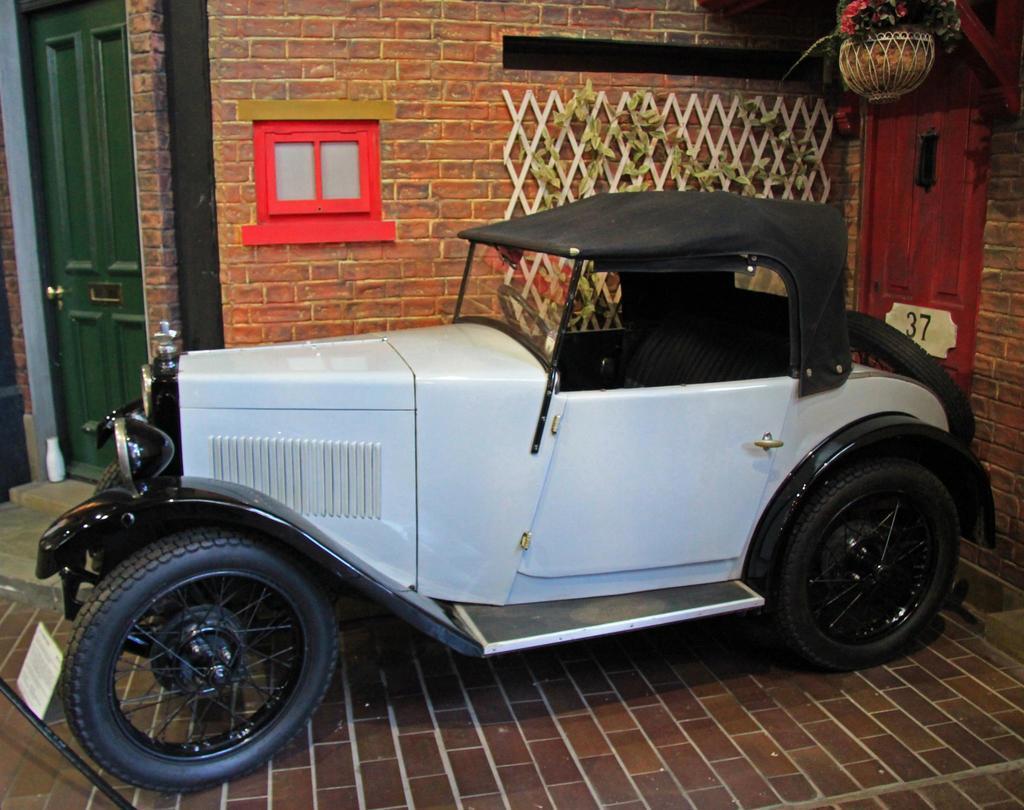In one or two sentences, can you explain what this image depicts? In this image we can see a vehicle. In the back there are doors and brick walls. On the wall there is a red color object and a wooden mesh with plants. At the top there is a pot with plant. 